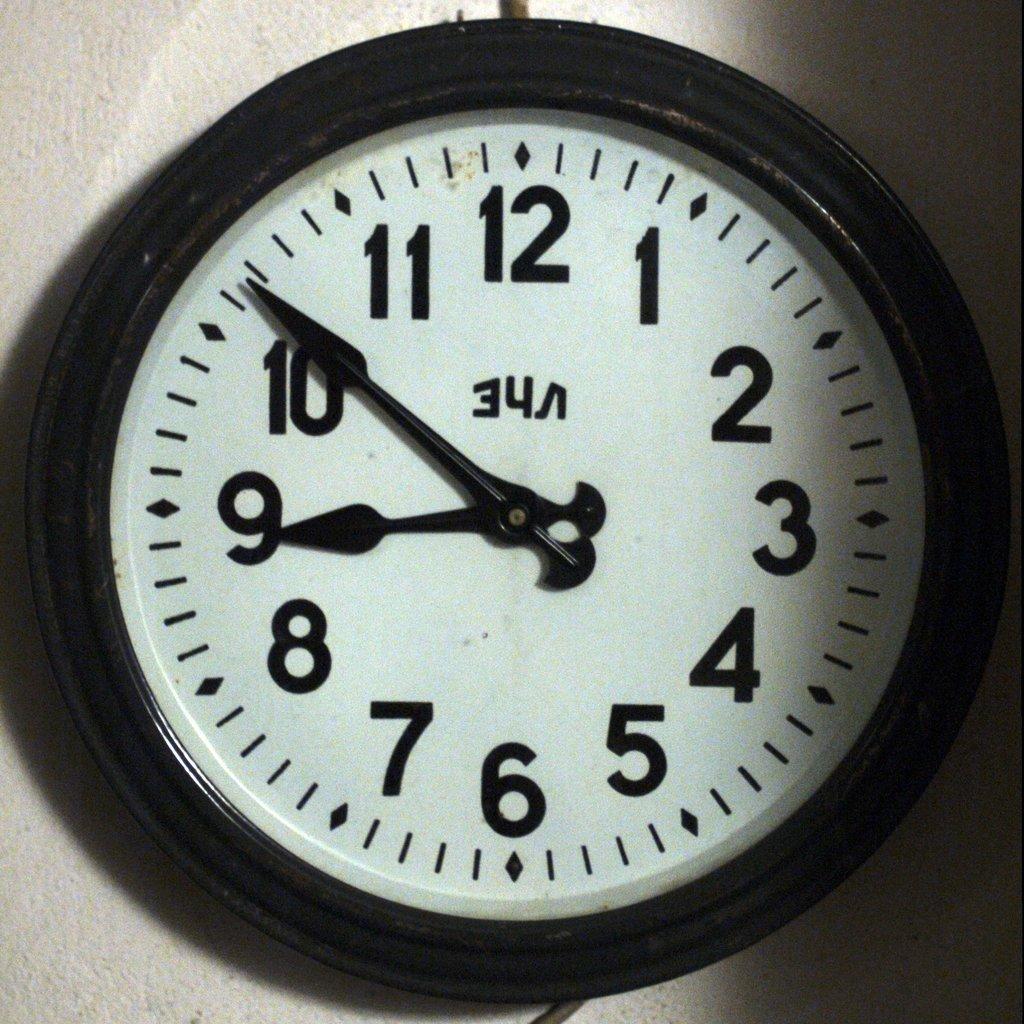What number is at the top?
Offer a very short reply. 12. What time does the clock say?
Make the answer very short. 8:51. 